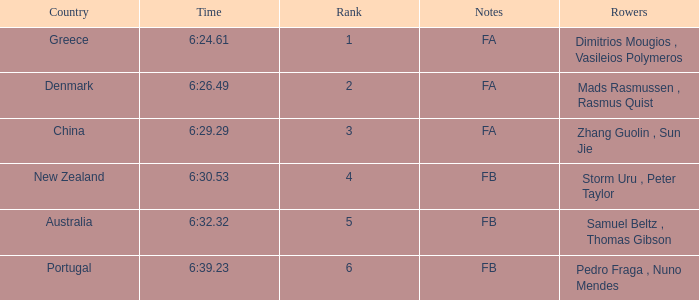What is the rank of the time of 6:30.53? 1.0. 